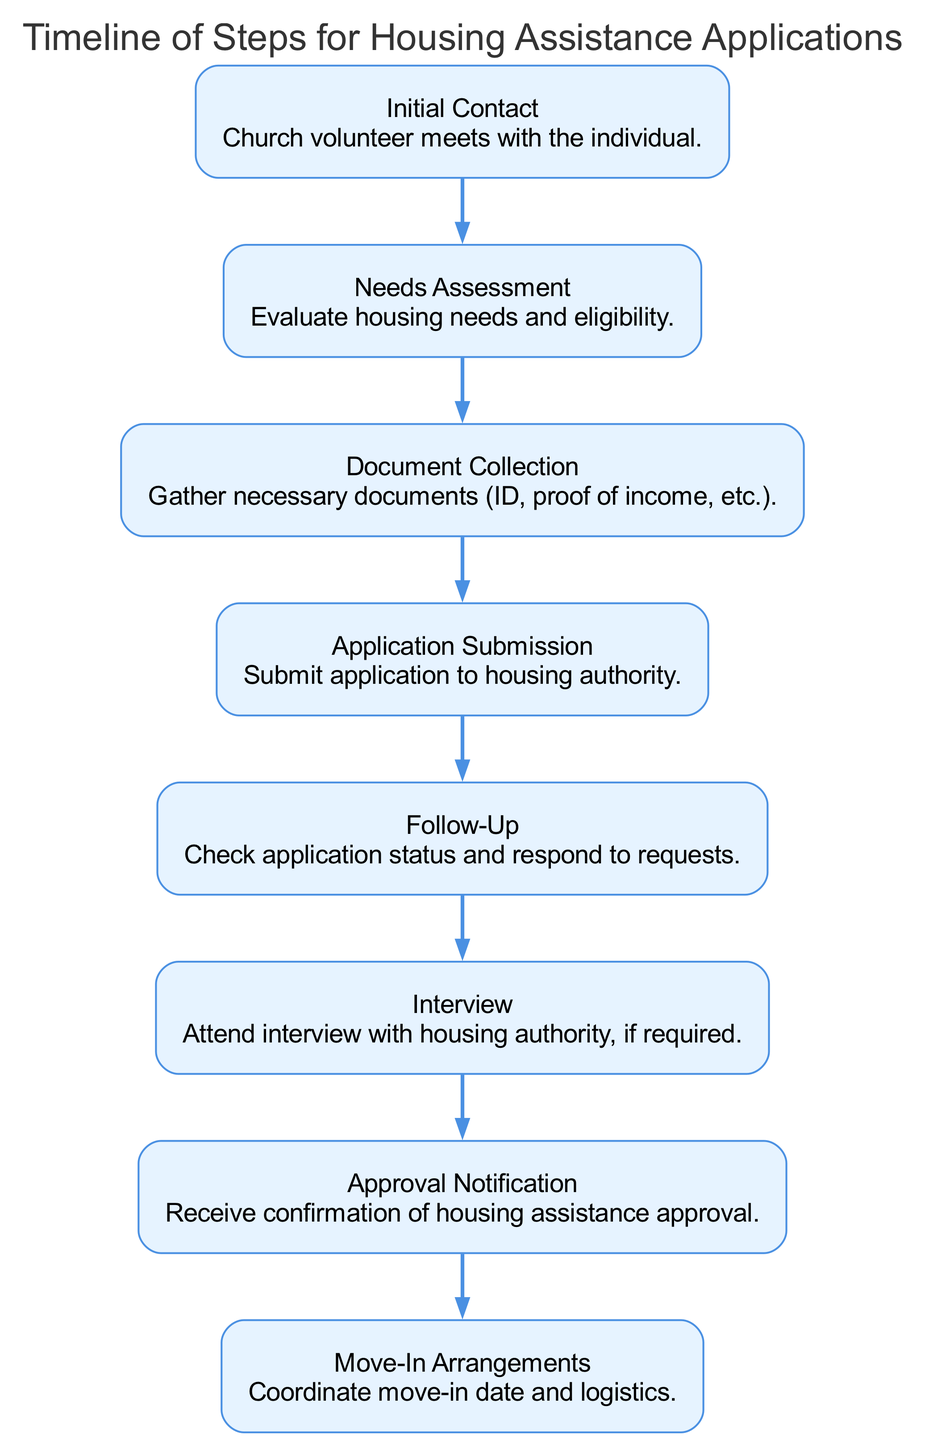What is the first step in the housing assistance application timeline? The first step in the timeline is labeled "Initial Contact," where the church volunteer meets with the individual. This information is located at the starting node of the diagram.
Answer: Initial Contact How many nodes are present in the diagram? The diagram contains a total of eight nodes, each representing a step in the housing assistance application process. This can be counted directly from the provided data.
Answer: 8 What is the step that follows the Needs Assessment? According to the flow of the diagram, the step that follows "Needs Assessment" is "Document Collection." This is determined by looking at the edges between the nodes.
Answer: Document Collection Which step comes before the Interview? The step that comes directly before "Interview" is "Follow-Up," as indicated by the directed edge connecting these two nodes. This means that one must complete the Follow-Up before moving to the Interview step.
Answer: Follow-Up How many steps are there between Application Submission and Move-In Arrangements? Between "Application Submission" and "Move-In Arrangements," there are three steps: "Follow-Up," "Interview," and "Approval Notification." Counting these steps gives a total of three.
Answer: 3 What is the final step in the application process? The final step in the application process is labeled "Move-In Arrangements." This is at the end of the timeline and corresponds to the last node in the diagram.
Answer: Move-In Arrangements Which step requires attending an interview? The step that requires attending an interview is "Interview." This is explicitly stated as part of the description for that node.
Answer: Interview What are the two nodes connected by the edge from step 6? The edge from step 6 ("Interview") connects to step 7, which is labeled "Approval Notification." This relationship can be observed by following the direction of the edges in the diagram.
Answer: Approval Notification What process follows the Approval Notification? Following "Approval Notification," the next process is "Move-In Arrangements," as indicated by the directed flow in the diagram. This means that once approval is received, the individual can start making moving arrangements.
Answer: Move-In Arrangements 